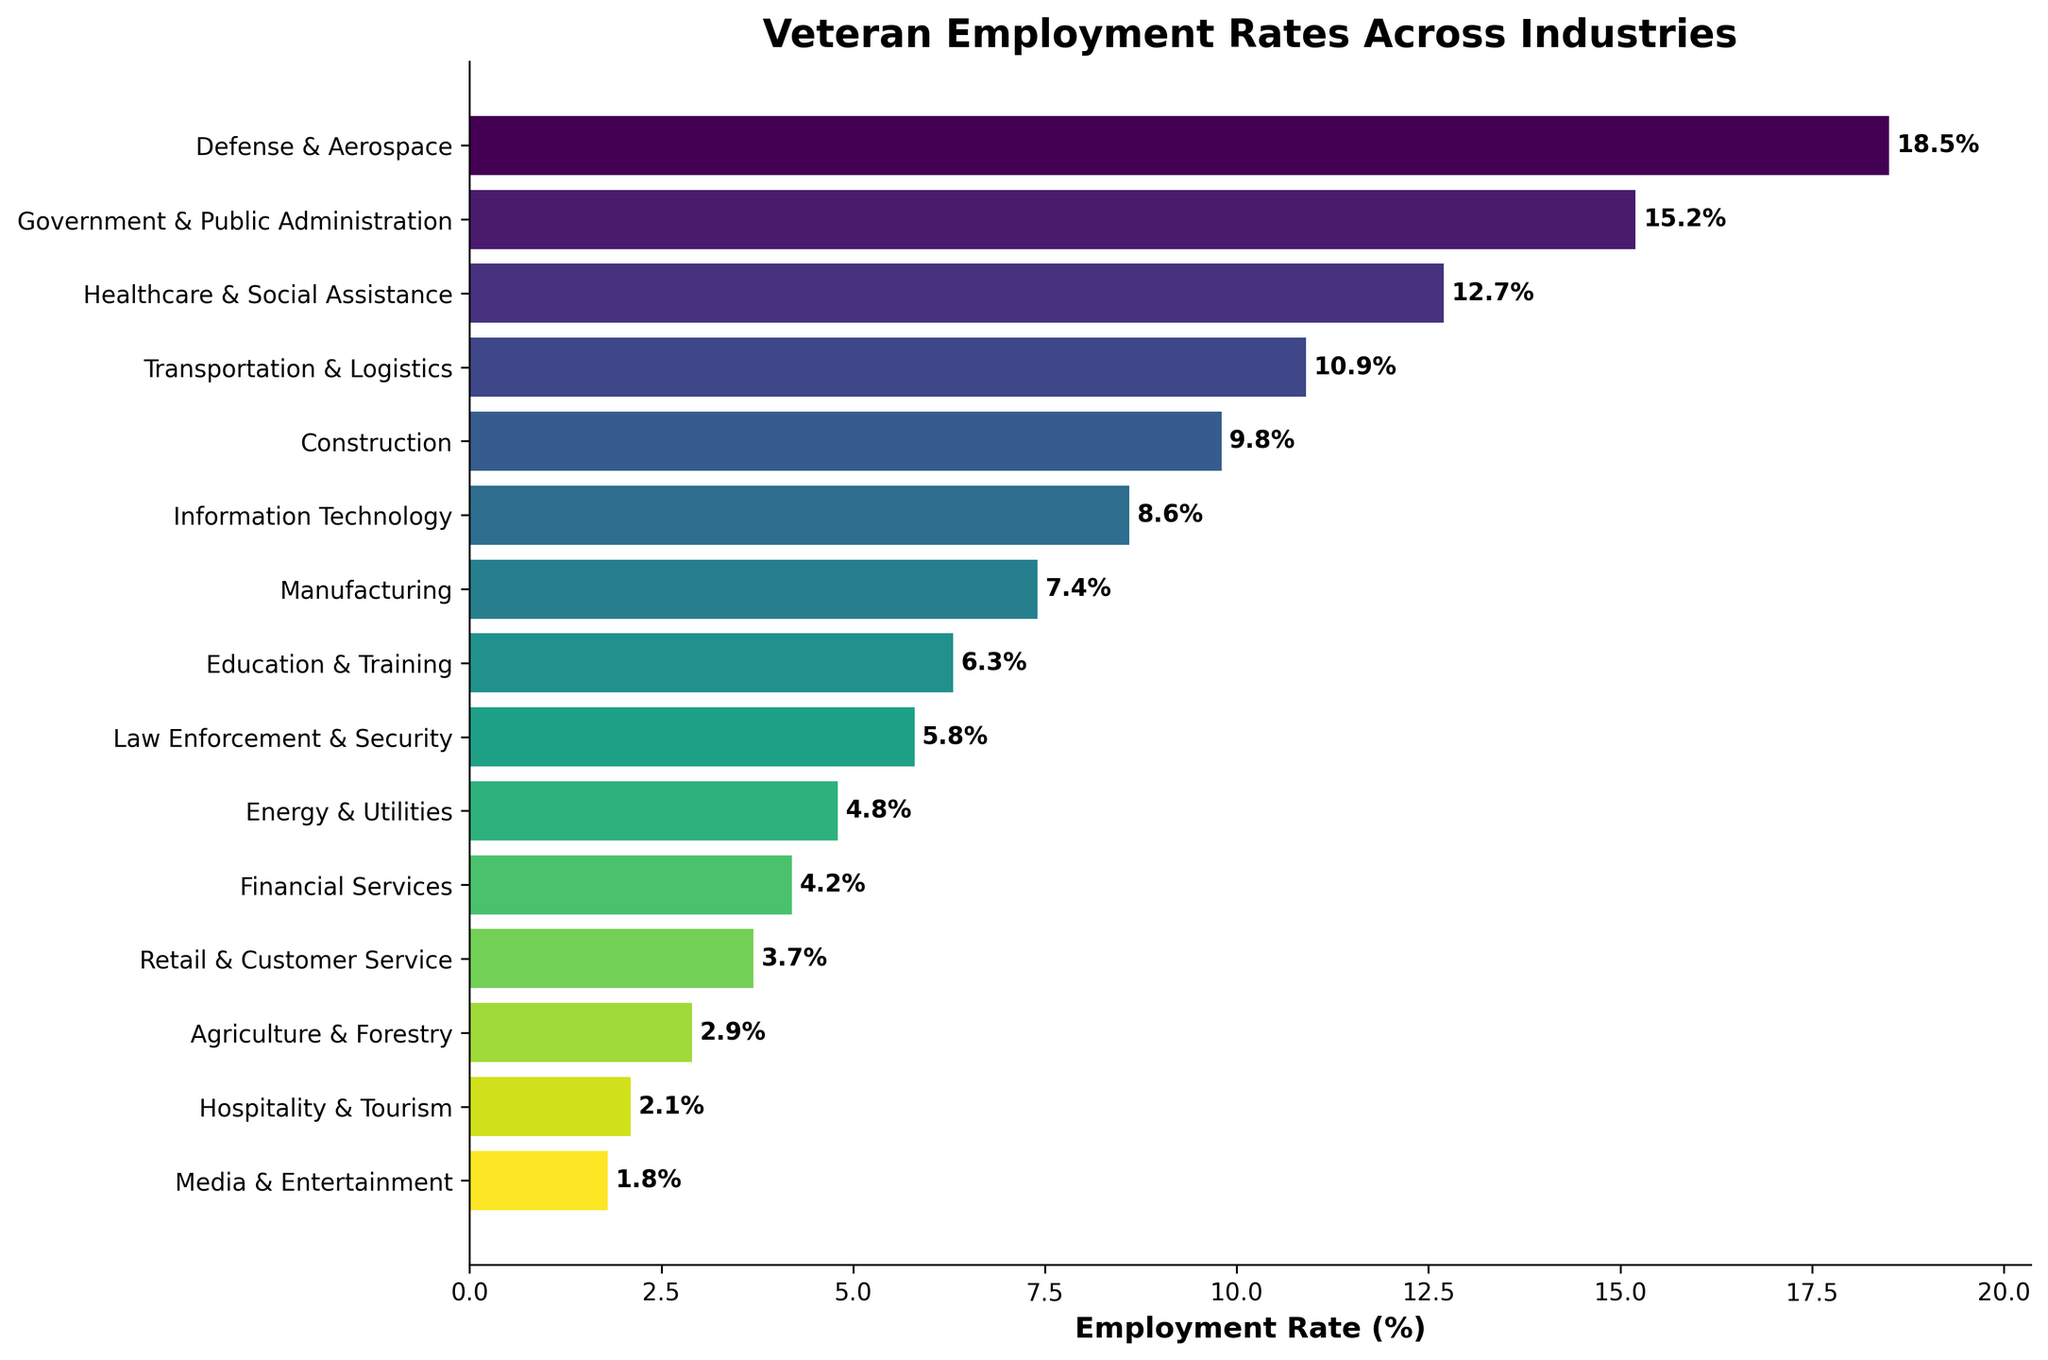Which industry employs the highest percentage of veterans? The bar chart shows the highest employment rate is for the "Defense & Aerospace" sector with a rate of 18.5%.
Answer: Defense & Aerospace What is the employment rate difference between Defense & Aerospace and Government & Public Administration? The employment rate for Defense & Aerospace is 18.5% and for Government & Public Administration it is 15.2%, the difference is 18.5% - 15.2% = 3.3%.
Answer: 3.3% Which industries have employment rates greater than 10%? The industries with employment rates greater than 10% are Defense & Aerospace (18.5%), Government & Public Administration (15.2%), Healthcare & Social Assistance (12.7%), and Transportation & Logistics (10.9%).
Answer: Defense & Aerospace, Government & Public Administration, Healthcare & Social Assistance, Transportation & Logistics What is the combined employment rate for Information Technology, Manufacturing, and Education & Training sectors? Combine the employment rates: Information Technology (8.6%), Manufacturing (7.4%), and Education & Training (6.3%). The total is 8.6% + 7.4% + 6.3% = 22.3%.
Answer: 22.3% How much higher is the employment rate in Healthcare & Social Assistance compared to Agriculture & Forestry? The employment rate for Healthcare & Social Assistance is 12.7% and for Agriculture & Forestry, it is 2.9%. The difference is 12.7% - 2.9% = 9.8%.
Answer: 9.8% Which sector has the lowest employment rate for veterans? The sector with the lowest employment rate is Media & Entertainment with a rate of 1.8%.
Answer: Media & Entertainment Compare the employment rates in Law Enforcement & Security and Financial Services. Which one has a higher rate and by how much? Law Enforcement & Security has an employment rate of 5.8%, whereas Financial Services has a rate of 4.2%. The difference is 5.8% - 4.2% = 1.6%, so Law Enforcement & Security has a higher rate by 1.6%.
Answer: Law Enforcement & Security, 1.6% What is the average employment rate across all displayed industries? Sum all employment rates and divide by the number of industries. (18.5% + 15.2% + 12.7% + 10.9% + 9.8% + 8.6% + 7.4% + 6.3% + 5.8% + 4.8% + 4.2% + 3.7% + 2.9% + 2.1% + 1.8%) / 15 = 114.7% / 15 ≈ 7.65%.
Answer: 7.65% Which color represents the "Energy & Utilities" sector on the bar chart? Verify the color gradient on the bar chart next to the "Energy & Utilities" sector bar. The sector is the tenth on the list, showing a specific color distinct from ones below it. The exact color cannot be stated without the visual, but it's towards a yellow-green in a gradient.
Answer: Yellow-Green 